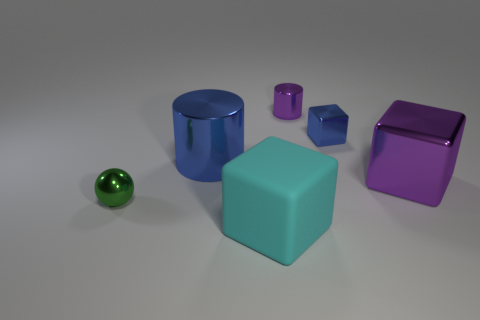How would you describe the arrangement of objects in this image? The objects are arranged spaced out from one another on a flat surface, possibly implying an organized display or a comparative setup to analyze their colors, shapes, or sizes. 